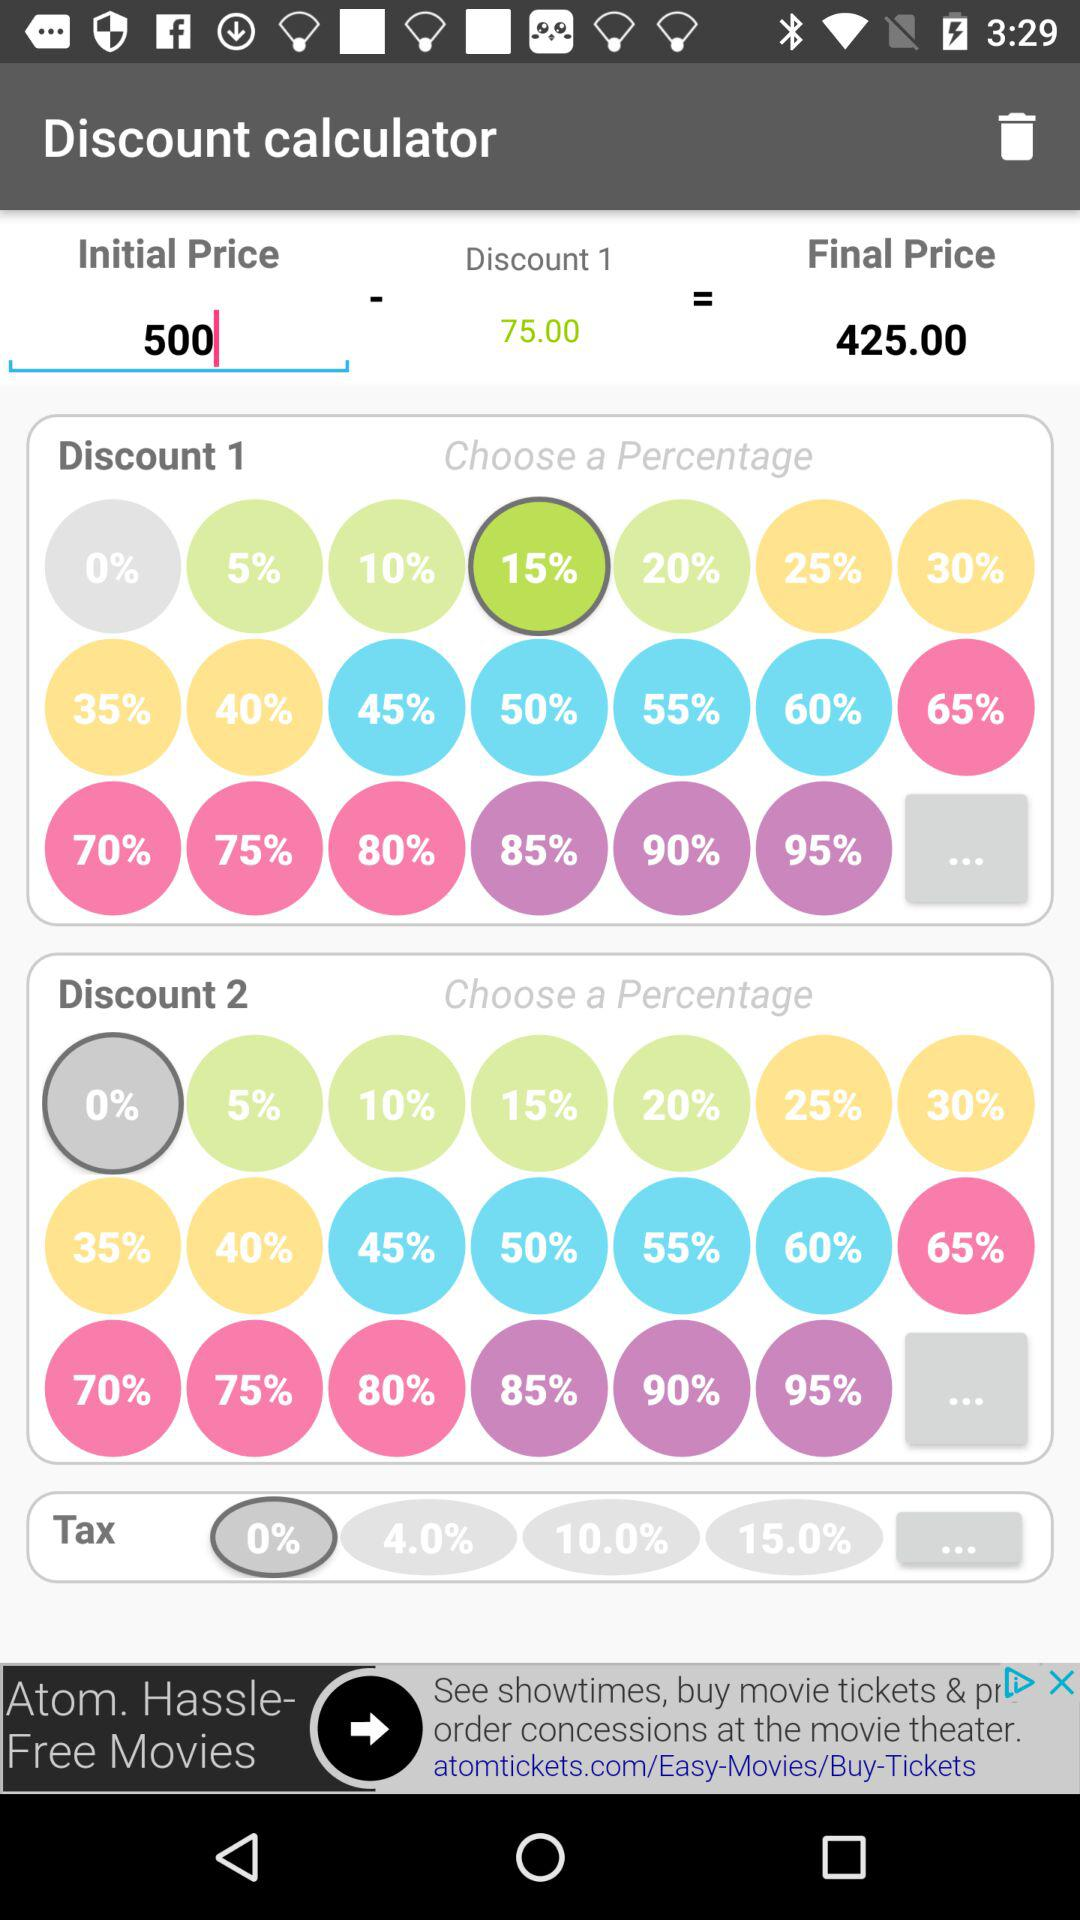How much is the final price? The final price is 425.00. 